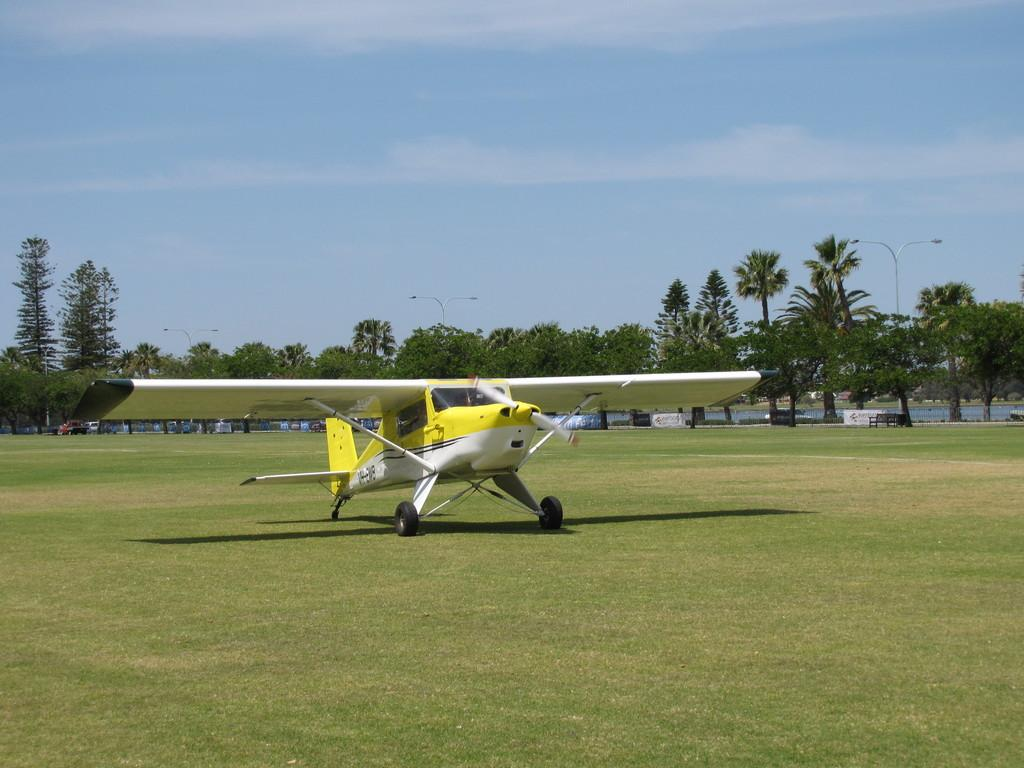What type of ground surface is visible in the front of the image? There is grass on the ground in the front of the image. What is the main subject in the center of the image? There is an airplane in the center of the image. What can be seen in the background of the image? There are trees and vehicles in the background of the image. How would you describe the sky in the image? The sky is cloudy in the image. What type of afterthought is being expressed by the mother in the image? There is no mother or afterthought present in the image. Is there any snow visible in the image? No, there is no snow visible in the image; the ground is covered with grass, and the sky is cloudy. 